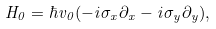<formula> <loc_0><loc_0><loc_500><loc_500>H _ { 0 } = \hbar { v } _ { 0 } ( - i \sigma _ { x } \partial _ { x } - i \sigma _ { y } \partial _ { y } ) ,</formula> 